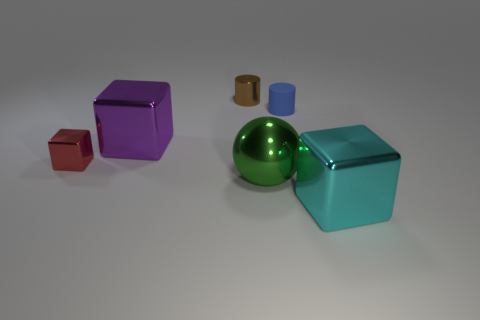Add 3 tiny red shiny objects. How many objects exist? 9 Subtract all balls. How many objects are left? 5 Subtract 1 green spheres. How many objects are left? 5 Subtract all cyan shiny blocks. Subtract all big purple cubes. How many objects are left? 4 Add 6 small cylinders. How many small cylinders are left? 8 Add 5 brown metallic cylinders. How many brown metallic cylinders exist? 6 